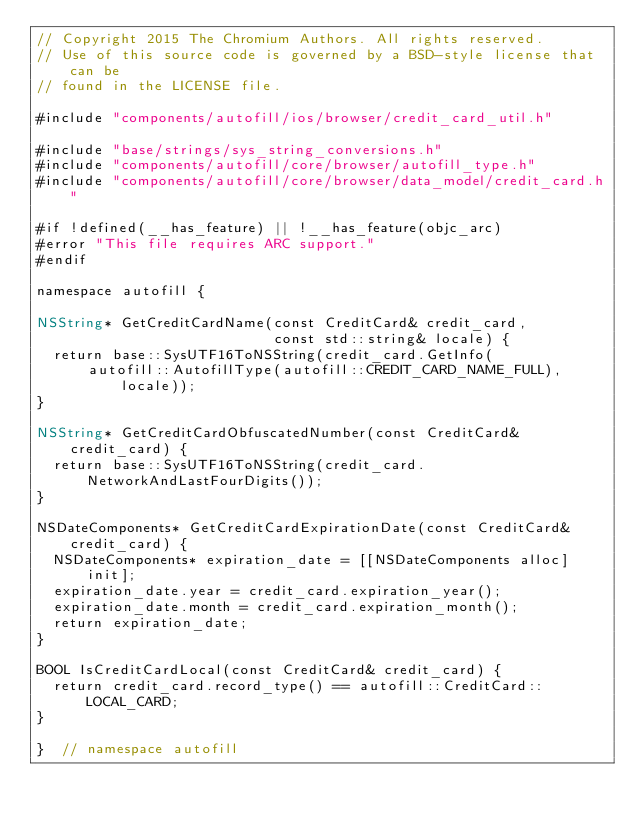Convert code to text. <code><loc_0><loc_0><loc_500><loc_500><_ObjectiveC_>// Copyright 2015 The Chromium Authors. All rights reserved.
// Use of this source code is governed by a BSD-style license that can be
// found in the LICENSE file.

#include "components/autofill/ios/browser/credit_card_util.h"

#include "base/strings/sys_string_conversions.h"
#include "components/autofill/core/browser/autofill_type.h"
#include "components/autofill/core/browser/data_model/credit_card.h"

#if !defined(__has_feature) || !__has_feature(objc_arc)
#error "This file requires ARC support."
#endif

namespace autofill {

NSString* GetCreditCardName(const CreditCard& credit_card,
                            const std::string& locale) {
  return base::SysUTF16ToNSString(credit_card.GetInfo(
      autofill::AutofillType(autofill::CREDIT_CARD_NAME_FULL), locale));
}

NSString* GetCreditCardObfuscatedNumber(const CreditCard& credit_card) {
  return base::SysUTF16ToNSString(credit_card.NetworkAndLastFourDigits());
}

NSDateComponents* GetCreditCardExpirationDate(const CreditCard& credit_card) {
  NSDateComponents* expiration_date = [[NSDateComponents alloc] init];
  expiration_date.year = credit_card.expiration_year();
  expiration_date.month = credit_card.expiration_month();
  return expiration_date;
}

BOOL IsCreditCardLocal(const CreditCard& credit_card) {
  return credit_card.record_type() == autofill::CreditCard::LOCAL_CARD;
}

}  // namespace autofill
</code> 